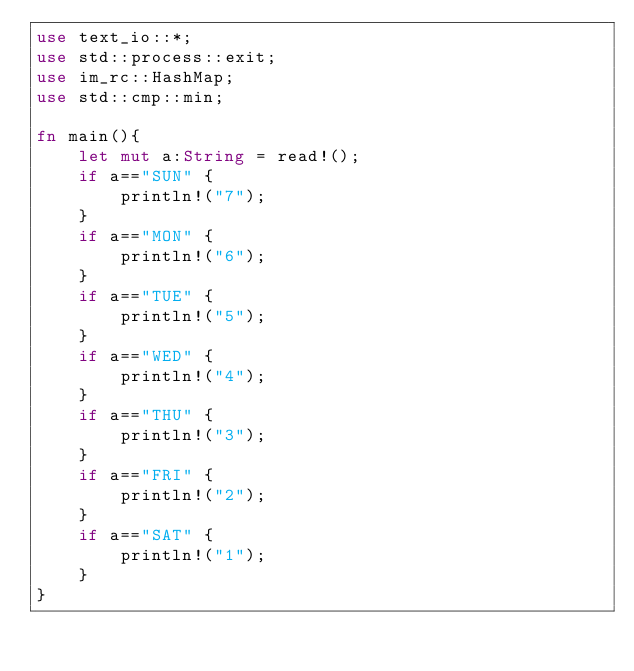Convert code to text. <code><loc_0><loc_0><loc_500><loc_500><_Rust_>use text_io::*;
use std::process::exit;
use im_rc::HashMap;
use std::cmp::min;

fn main(){
    let mut a:String = read!();
    if a=="SUN" {
        println!("7");
    }
    if a=="MON" {
        println!("6");
    }
    if a=="TUE" {
        println!("5");
    }
    if a=="WED" {
        println!("4");
    }
    if a=="THU" {
        println!("3");
    }
    if a=="FRI" {
        println!("2");
    }
    if a=="SAT" {
        println!("1");
    }
}</code> 